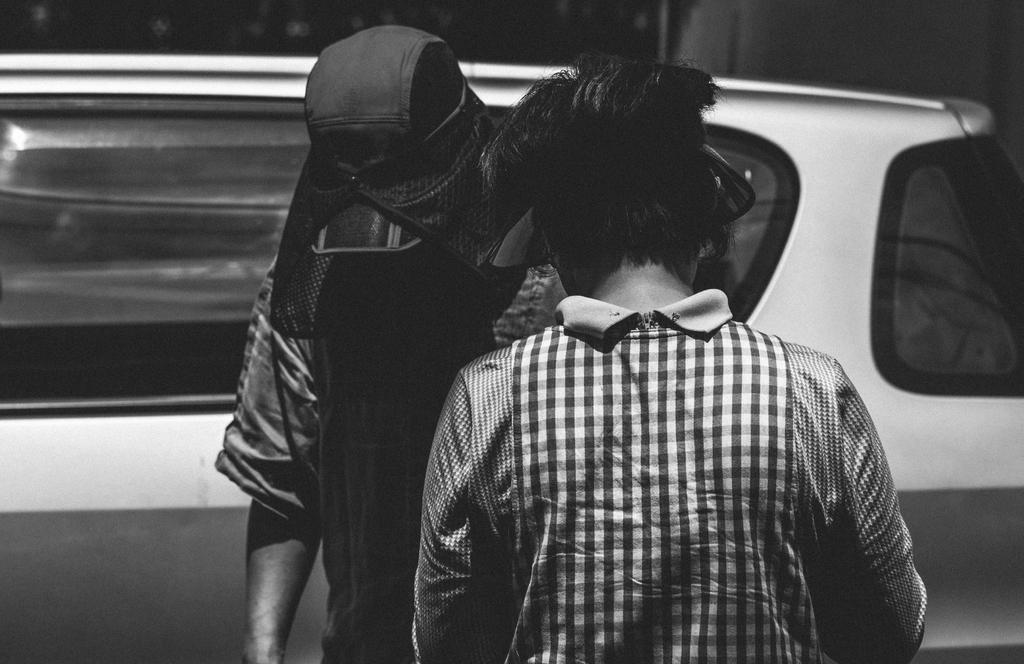How would you summarize this image in a sentence or two? In this image I can see 2 people in the front. There is a car at the back and this is a black and white image. 